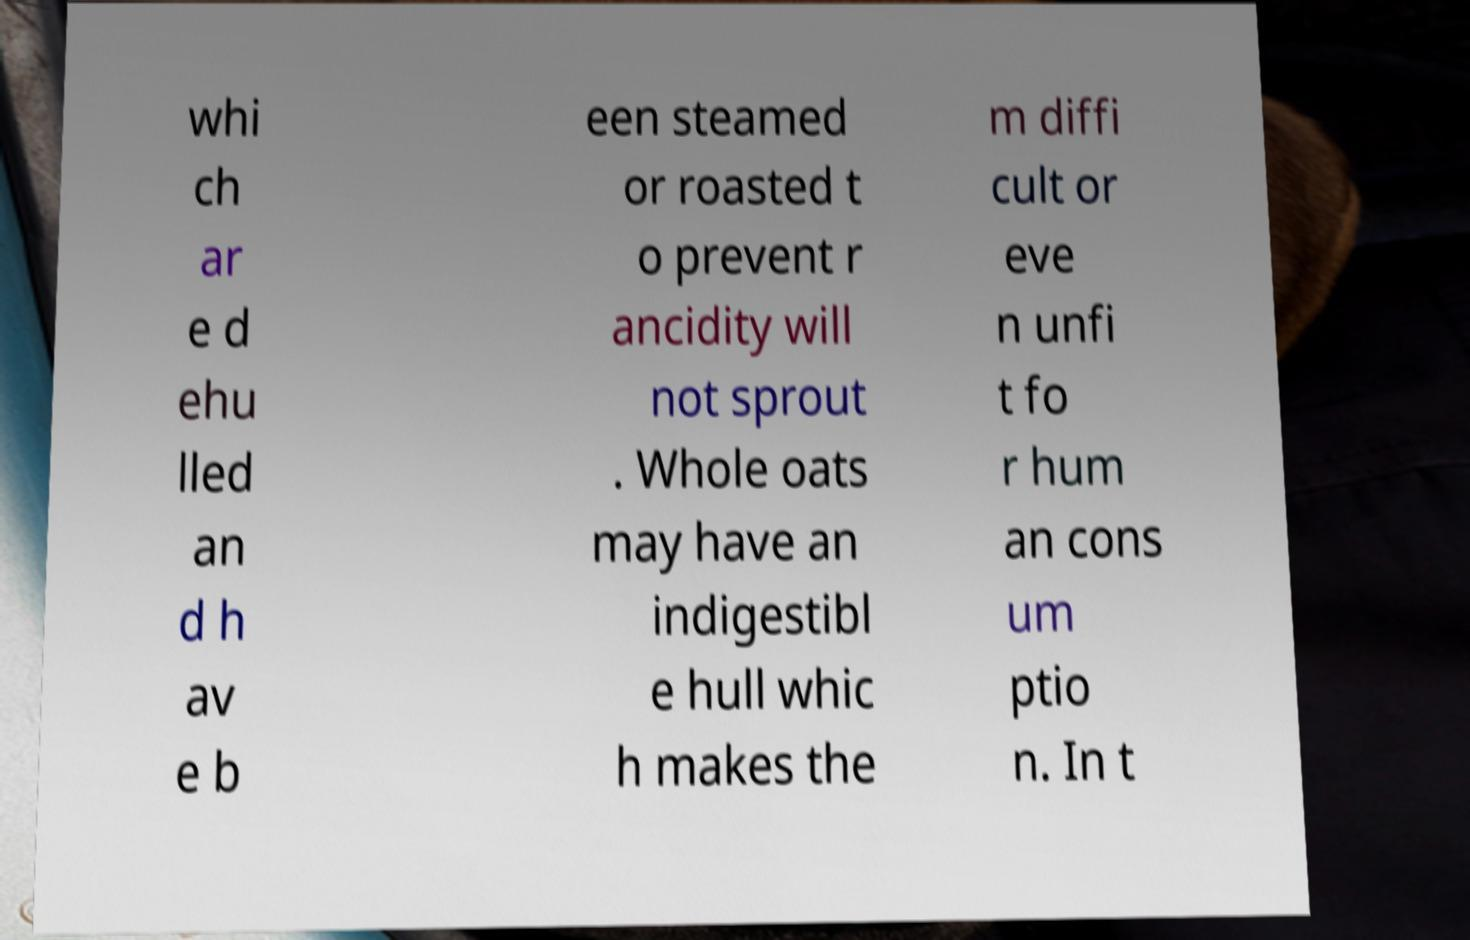I need the written content from this picture converted into text. Can you do that? whi ch ar e d ehu lled an d h av e b een steamed or roasted t o prevent r ancidity will not sprout . Whole oats may have an indigestibl e hull whic h makes the m diffi cult or eve n unfi t fo r hum an cons um ptio n. In t 